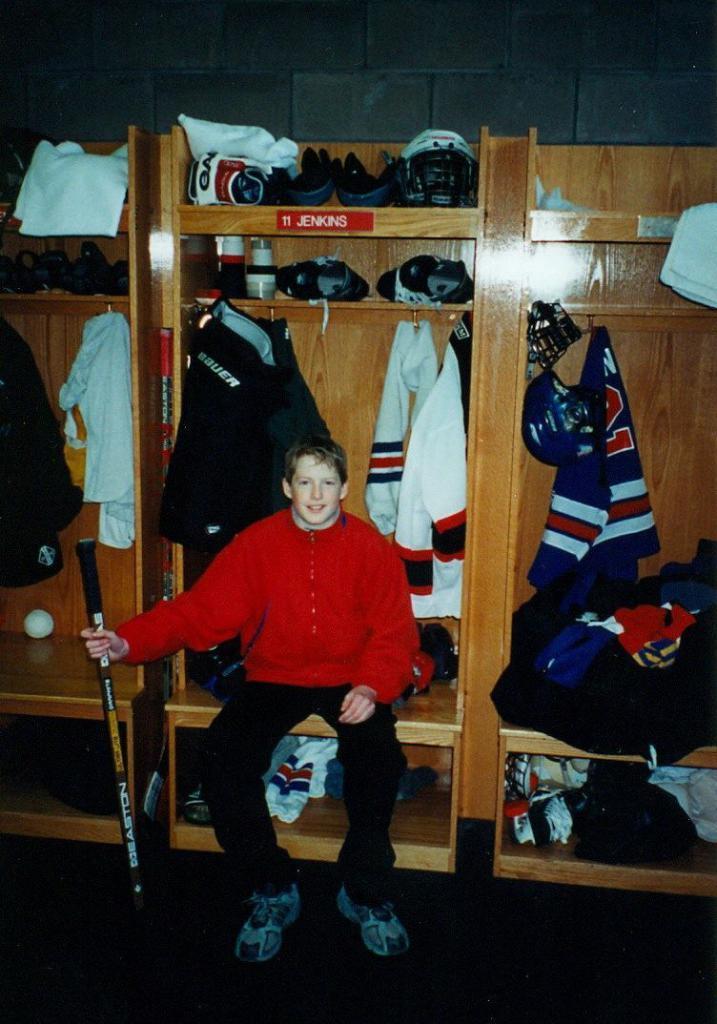In one or two sentences, can you explain what this image depicts? In this image I can see the person with red and black color dress and holding the stick. In the background I can see the cupboard with many clothes hanged to the hook, gloves, helmet and few more clothes. And I can see the grey color background. 